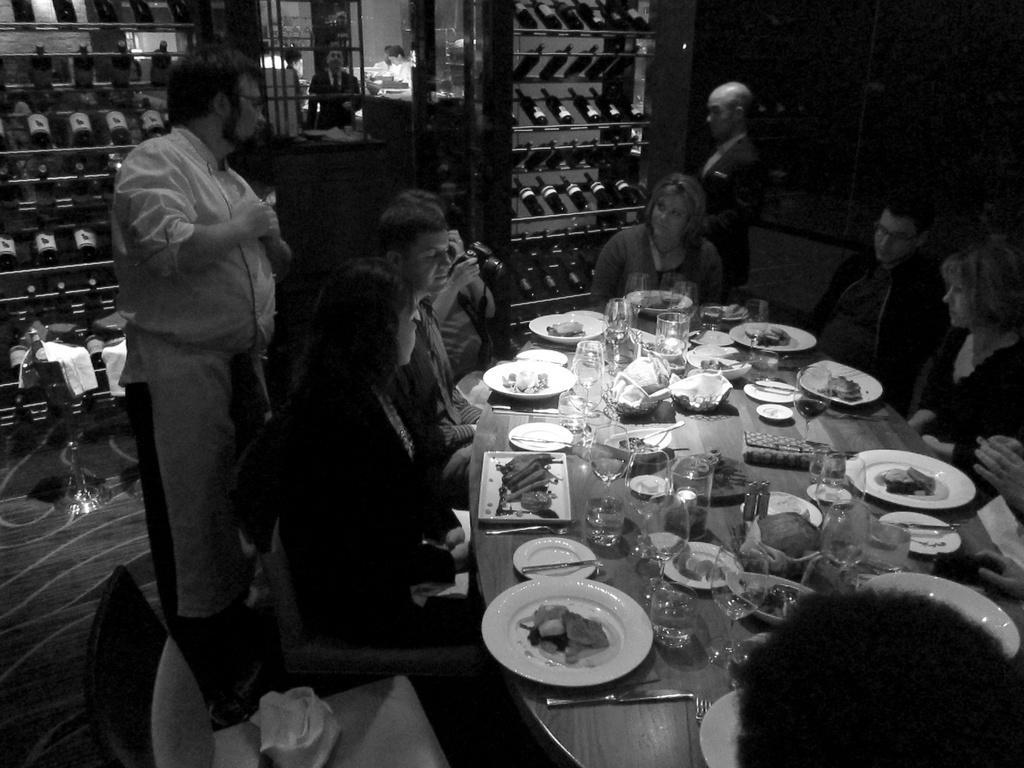Could you give a brief overview of what you see in this image? In this image I can see number of people where two of them are standing and rest all are sitting. Here on this table I can see number of plates, glasses and napkins. 